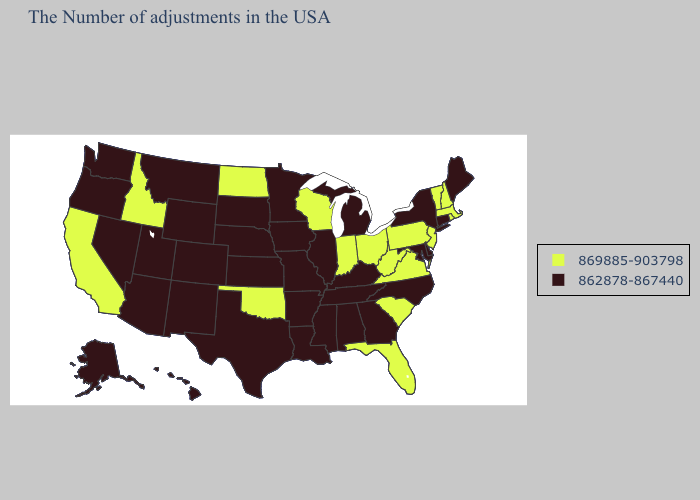Name the states that have a value in the range 869885-903798?
Short answer required. Massachusetts, Rhode Island, New Hampshire, Vermont, New Jersey, Pennsylvania, Virginia, South Carolina, West Virginia, Ohio, Florida, Indiana, Wisconsin, Oklahoma, North Dakota, Idaho, California. Which states have the lowest value in the South?
Write a very short answer. Delaware, Maryland, North Carolina, Georgia, Kentucky, Alabama, Tennessee, Mississippi, Louisiana, Arkansas, Texas. What is the value of Mississippi?
Concise answer only. 862878-867440. Does Missouri have the highest value in the USA?
Write a very short answer. No. Does California have the lowest value in the West?
Concise answer only. No. Does Nevada have the highest value in the West?
Answer briefly. No. Does Michigan have a lower value than Hawaii?
Give a very brief answer. No. Among the states that border California , which have the lowest value?
Concise answer only. Arizona, Nevada, Oregon. What is the value of Connecticut?
Be succinct. 862878-867440. Name the states that have a value in the range 862878-867440?
Give a very brief answer. Maine, Connecticut, New York, Delaware, Maryland, North Carolina, Georgia, Michigan, Kentucky, Alabama, Tennessee, Illinois, Mississippi, Louisiana, Missouri, Arkansas, Minnesota, Iowa, Kansas, Nebraska, Texas, South Dakota, Wyoming, Colorado, New Mexico, Utah, Montana, Arizona, Nevada, Washington, Oregon, Alaska, Hawaii. Name the states that have a value in the range 869885-903798?
Answer briefly. Massachusetts, Rhode Island, New Hampshire, Vermont, New Jersey, Pennsylvania, Virginia, South Carolina, West Virginia, Ohio, Florida, Indiana, Wisconsin, Oklahoma, North Dakota, Idaho, California. Name the states that have a value in the range 869885-903798?
Write a very short answer. Massachusetts, Rhode Island, New Hampshire, Vermont, New Jersey, Pennsylvania, Virginia, South Carolina, West Virginia, Ohio, Florida, Indiana, Wisconsin, Oklahoma, North Dakota, Idaho, California. Name the states that have a value in the range 869885-903798?
Quick response, please. Massachusetts, Rhode Island, New Hampshire, Vermont, New Jersey, Pennsylvania, Virginia, South Carolina, West Virginia, Ohio, Florida, Indiana, Wisconsin, Oklahoma, North Dakota, Idaho, California. What is the value of Rhode Island?
Keep it brief. 869885-903798. Which states have the highest value in the USA?
Keep it brief. Massachusetts, Rhode Island, New Hampshire, Vermont, New Jersey, Pennsylvania, Virginia, South Carolina, West Virginia, Ohio, Florida, Indiana, Wisconsin, Oklahoma, North Dakota, Idaho, California. 